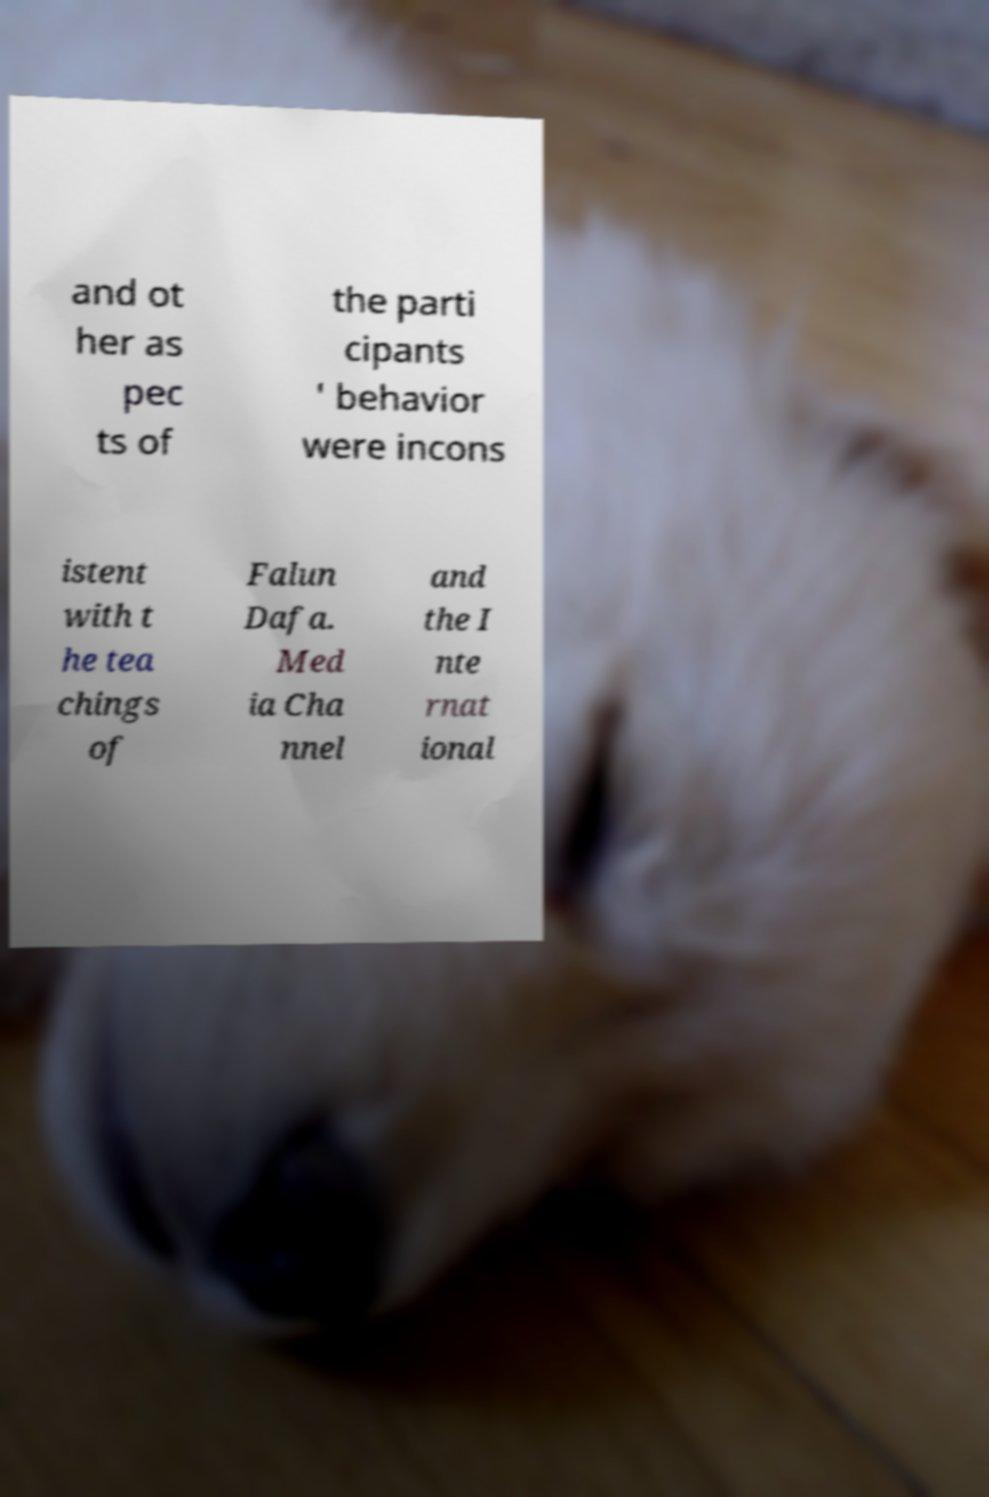Please identify and transcribe the text found in this image. and ot her as pec ts of the parti cipants ' behavior were incons istent with t he tea chings of Falun Dafa. Med ia Cha nnel and the I nte rnat ional 